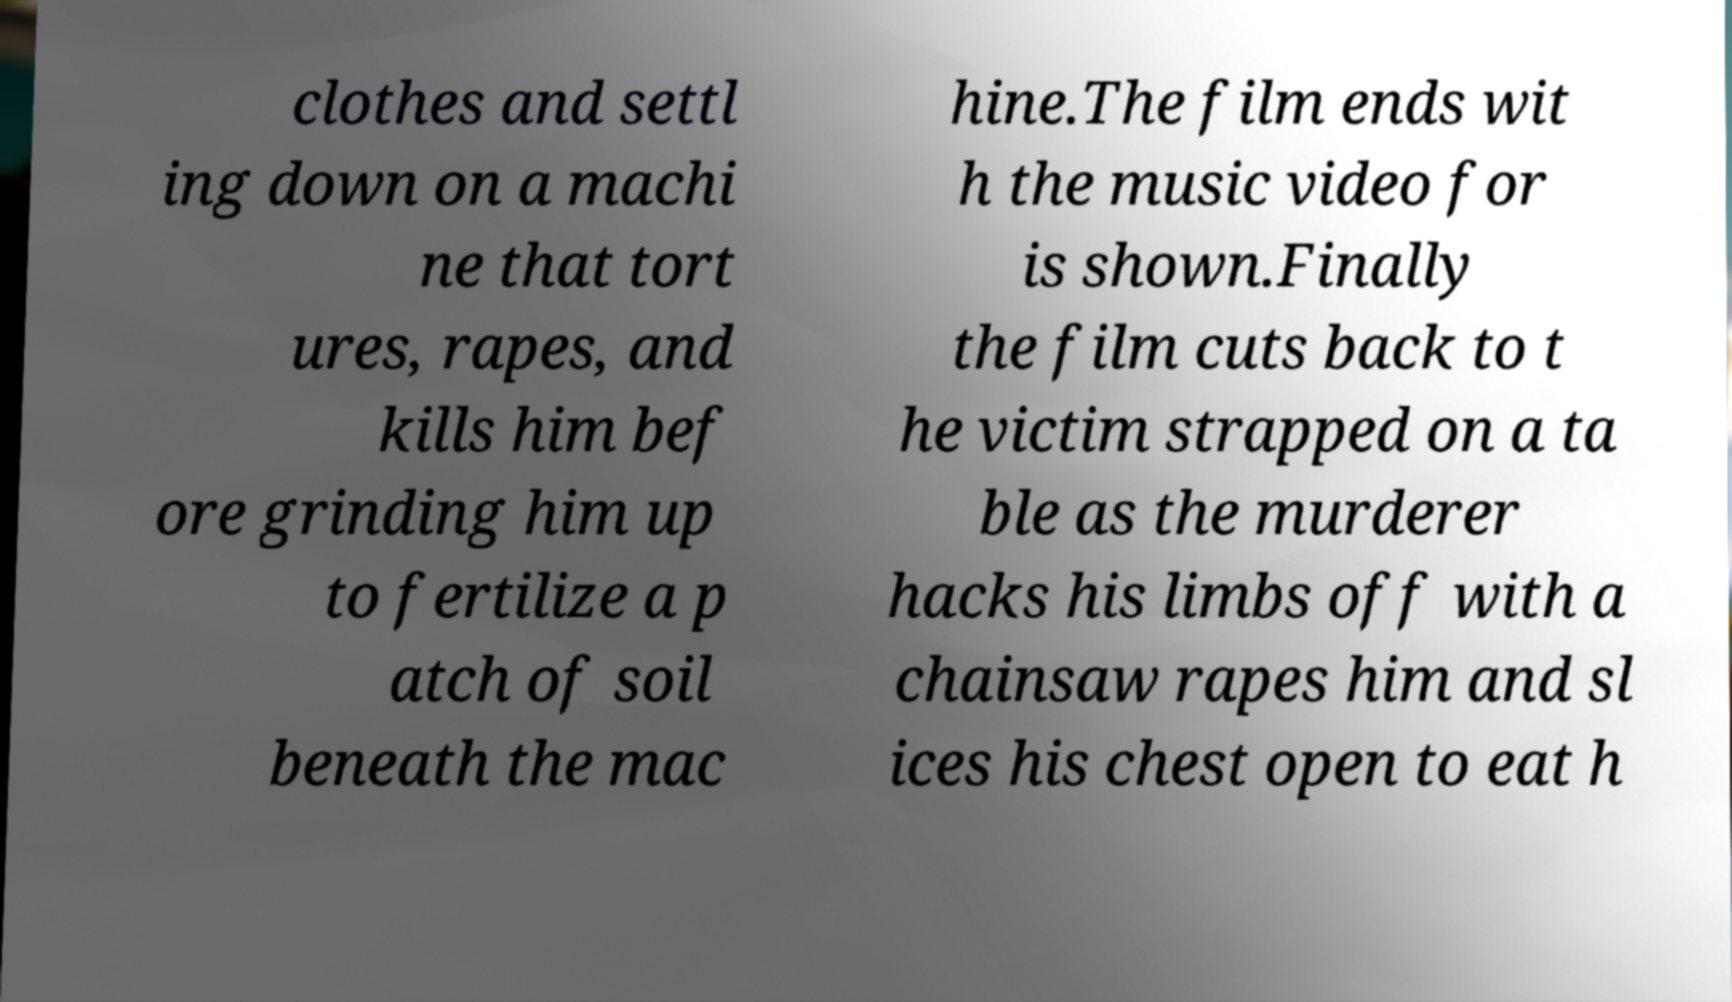For documentation purposes, I need the text within this image transcribed. Could you provide that? clothes and settl ing down on a machi ne that tort ures, rapes, and kills him bef ore grinding him up to fertilize a p atch of soil beneath the mac hine.The film ends wit h the music video for is shown.Finally the film cuts back to t he victim strapped on a ta ble as the murderer hacks his limbs off with a chainsaw rapes him and sl ices his chest open to eat h 